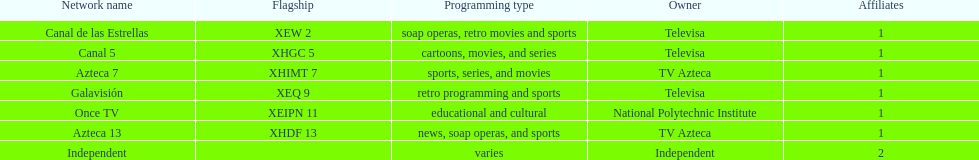What is the number of networks that do not broadcast sports? 2. 